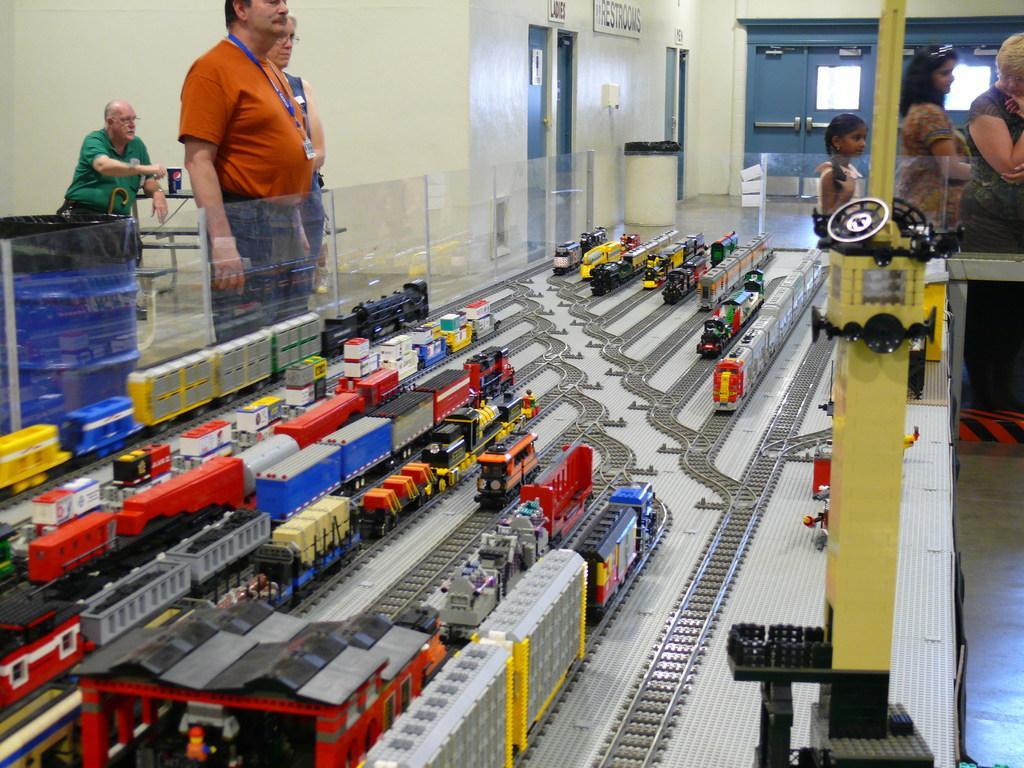In one or two sentences, can you explain what this image depicts? In the middle of the picture, we see toy trains are placed on the railway tracks. Beside that, the man in orange T-shirt and the woman in blue dress is stunning. Beside them, we see a blue color garbage bin. Beside that, the man in green T-shirt is sitting on the chair. In front of him, we see a table on which blue color cap is placed. Behind that, we see a wall in white color. On the right side, we see women are standing. In the background, we see a white color garbage bin and a wall in white and blue color. This picture might be clicked in the science fair. 